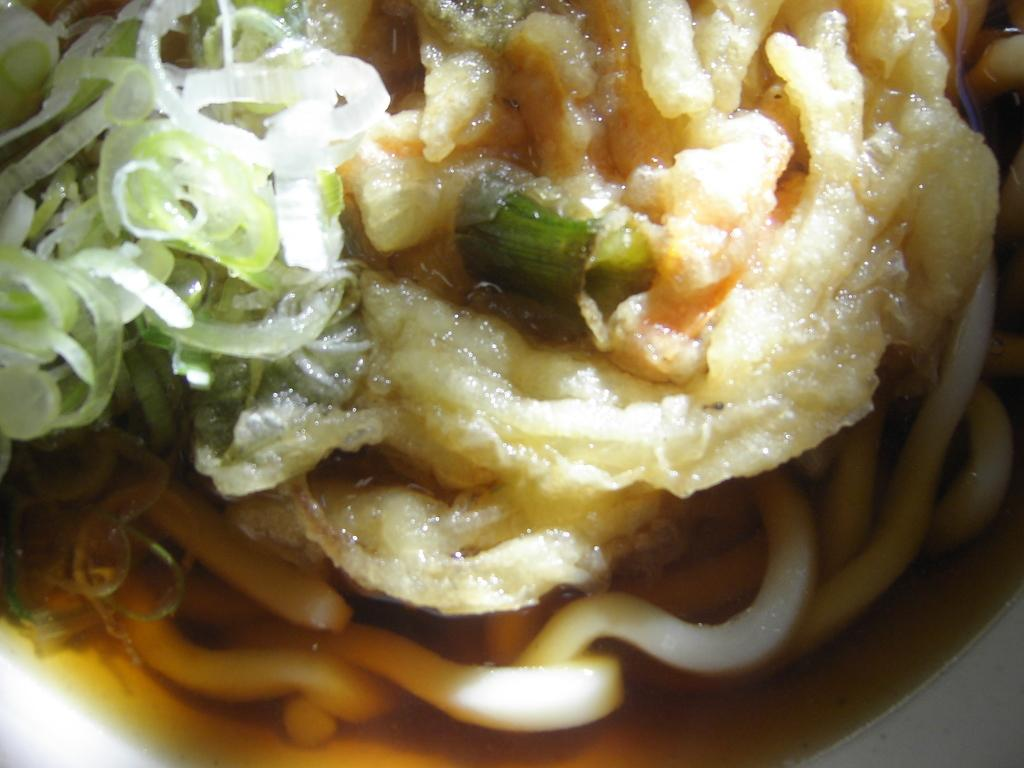What is the main subject of the image? There is a food item in the image. Can you describe the object that the food item is on? The food item is on an object. What type of furniture is visible in the image? There is no furniture present in the image. What type of spoon is used to serve the food item in the image? There is no spoon present in the image. 